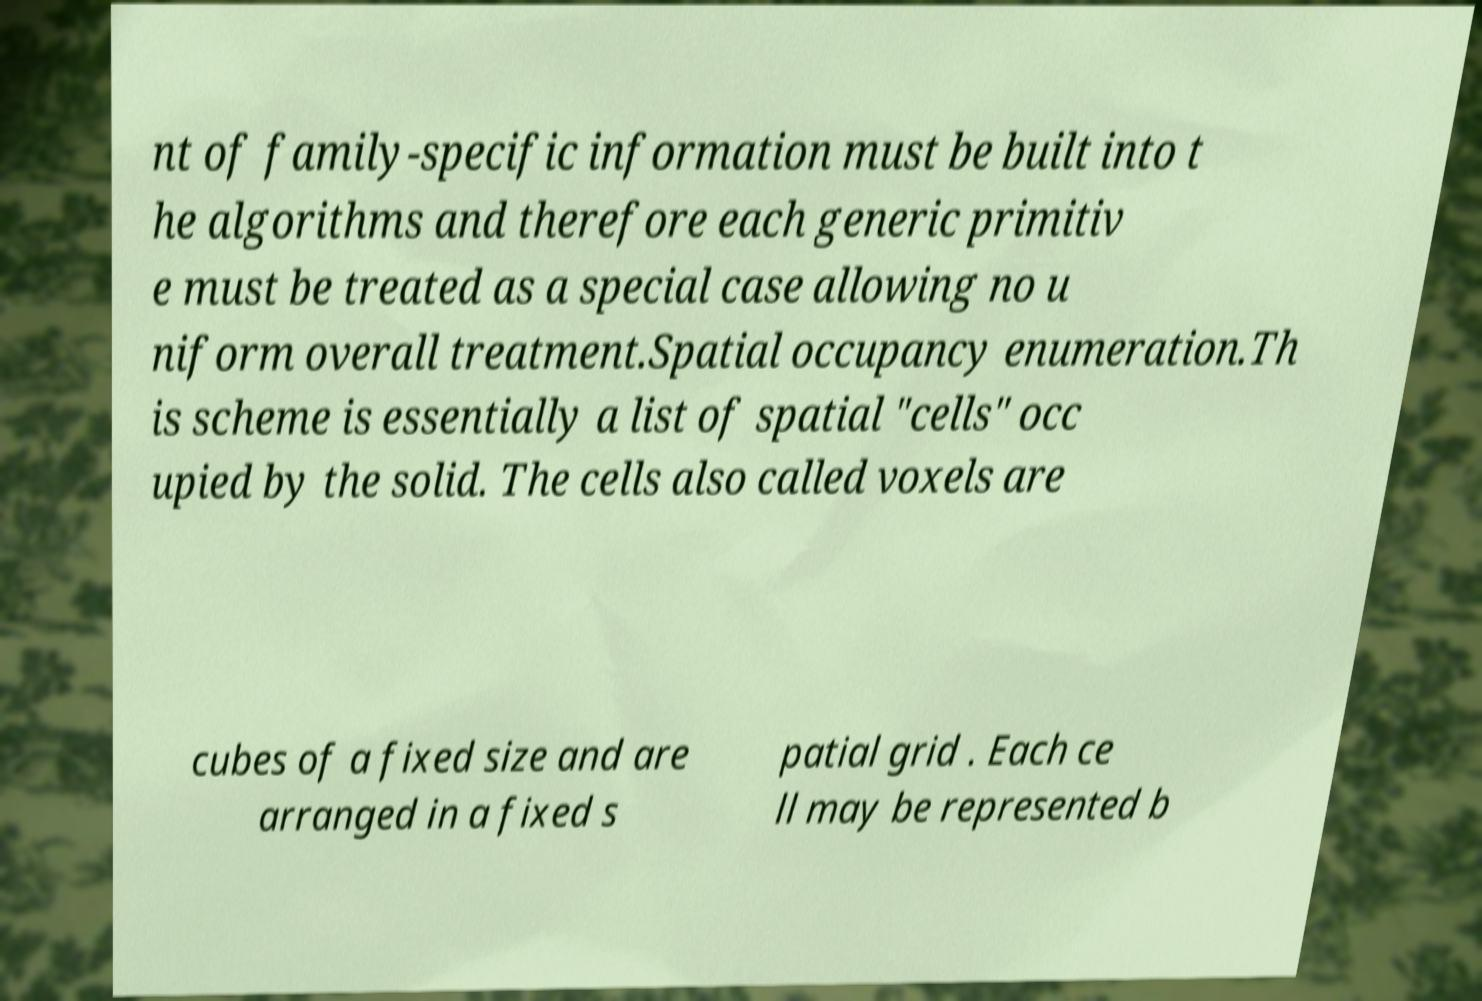Could you assist in decoding the text presented in this image and type it out clearly? nt of family-specific information must be built into t he algorithms and therefore each generic primitiv e must be treated as a special case allowing no u niform overall treatment.Spatial occupancy enumeration.Th is scheme is essentially a list of spatial "cells" occ upied by the solid. The cells also called voxels are cubes of a fixed size and are arranged in a fixed s patial grid . Each ce ll may be represented b 